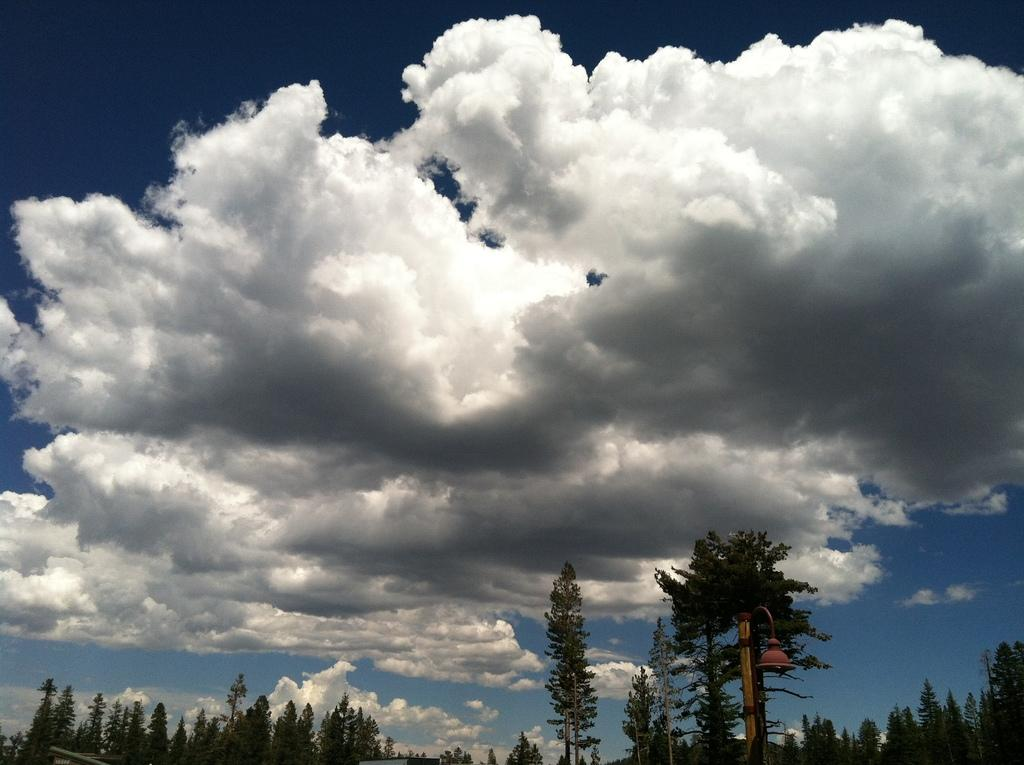What type of vegetation can be seen in the image? There are trees in the image. How would you describe the sky in the image? The sky is blue and cloudy in the image. What type of vessel is being used to provide shade in the image? There is no vessel or shade present in the image; it only features trees and a blue, cloudy sky. Can you see a ship sailing in the image? There is no ship visible in the image. 